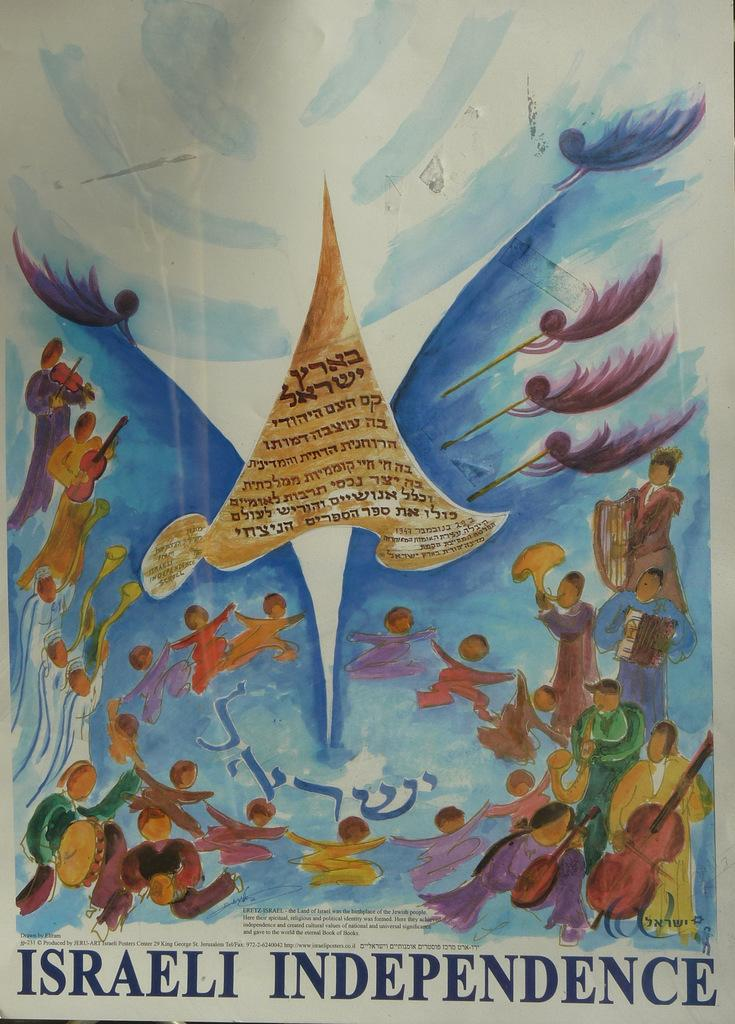What is the primary object in the image that contains text? There is a paper with text in the image. What type of artwork is present in the image? There is a painting in the image. What activities are depicted in the painting? The painting depicts people playing musical instruments and people dancing. What type of cloth is used to create the painting in the image? The painting is not made of cloth; it is a two-dimensional representation of people playing musical instruments and dancing. 